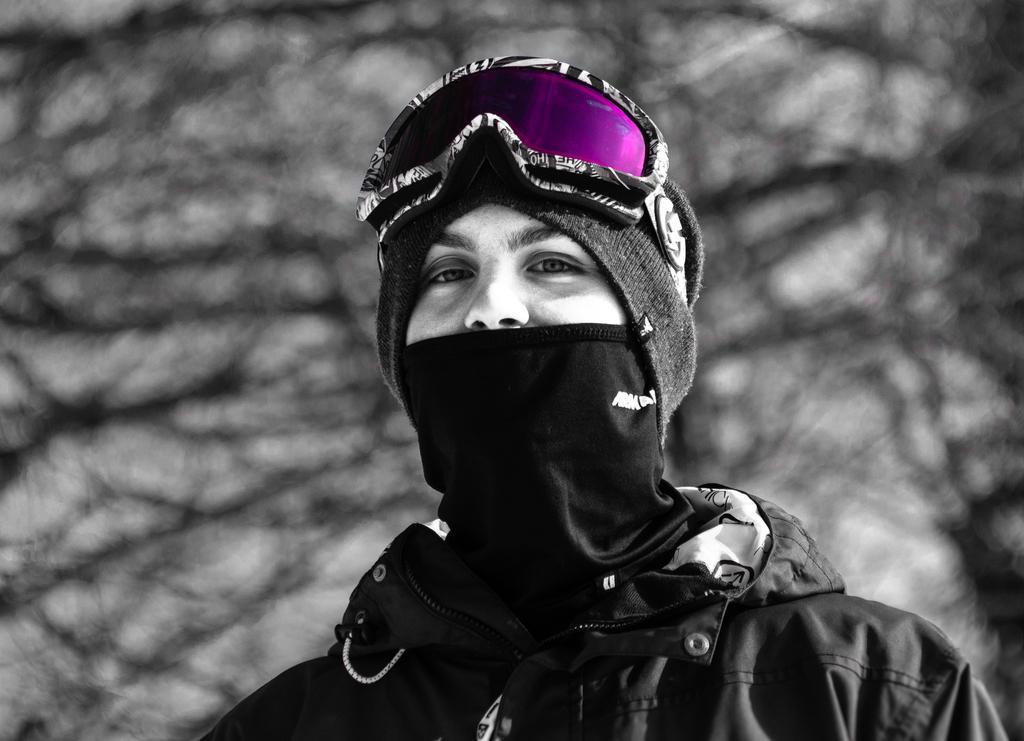Describe this image in one or two sentences. This is a edited image. In the center of the image we can see a person and wearing goggles, hat, coat. In the background of the image we can see the twigs. 